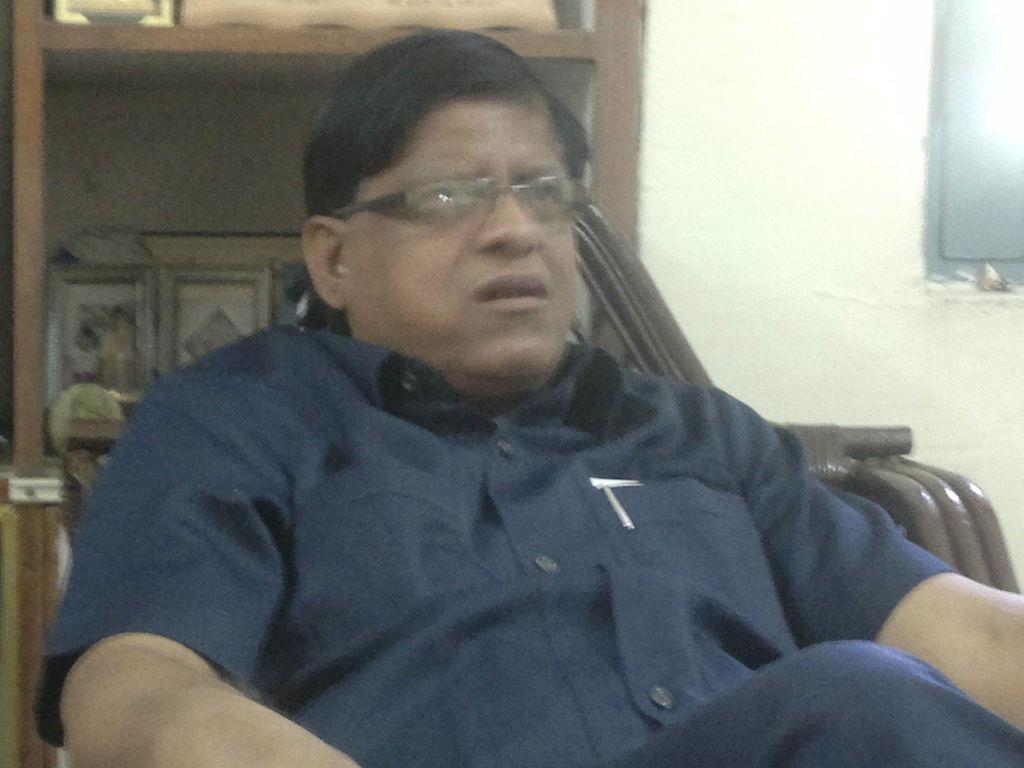In one or two sentences, can you explain what this image depicts? In this image we can see a person sitting on a chair, in the background there is a shelf with photo frames and a TV on the right side. 